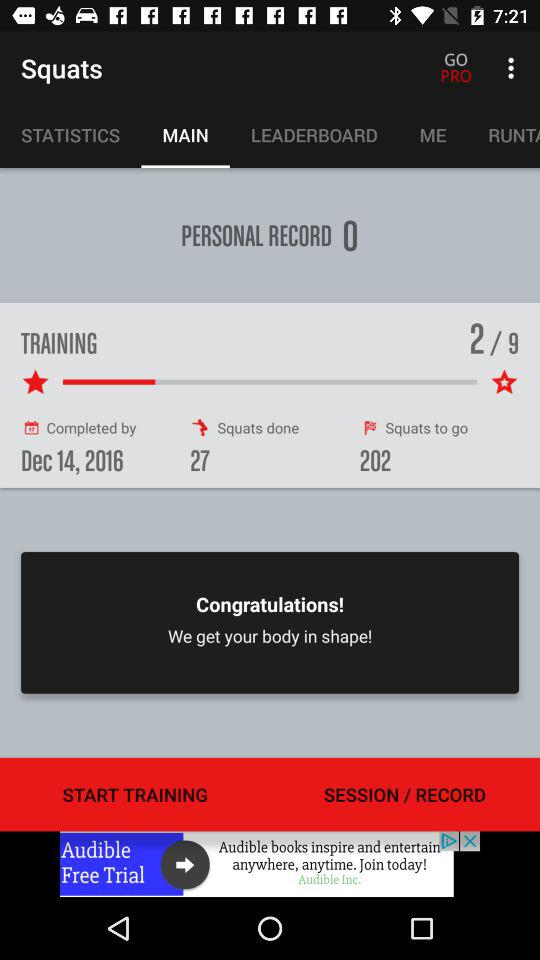What is the number of squats done? The number of squats done is 27. 